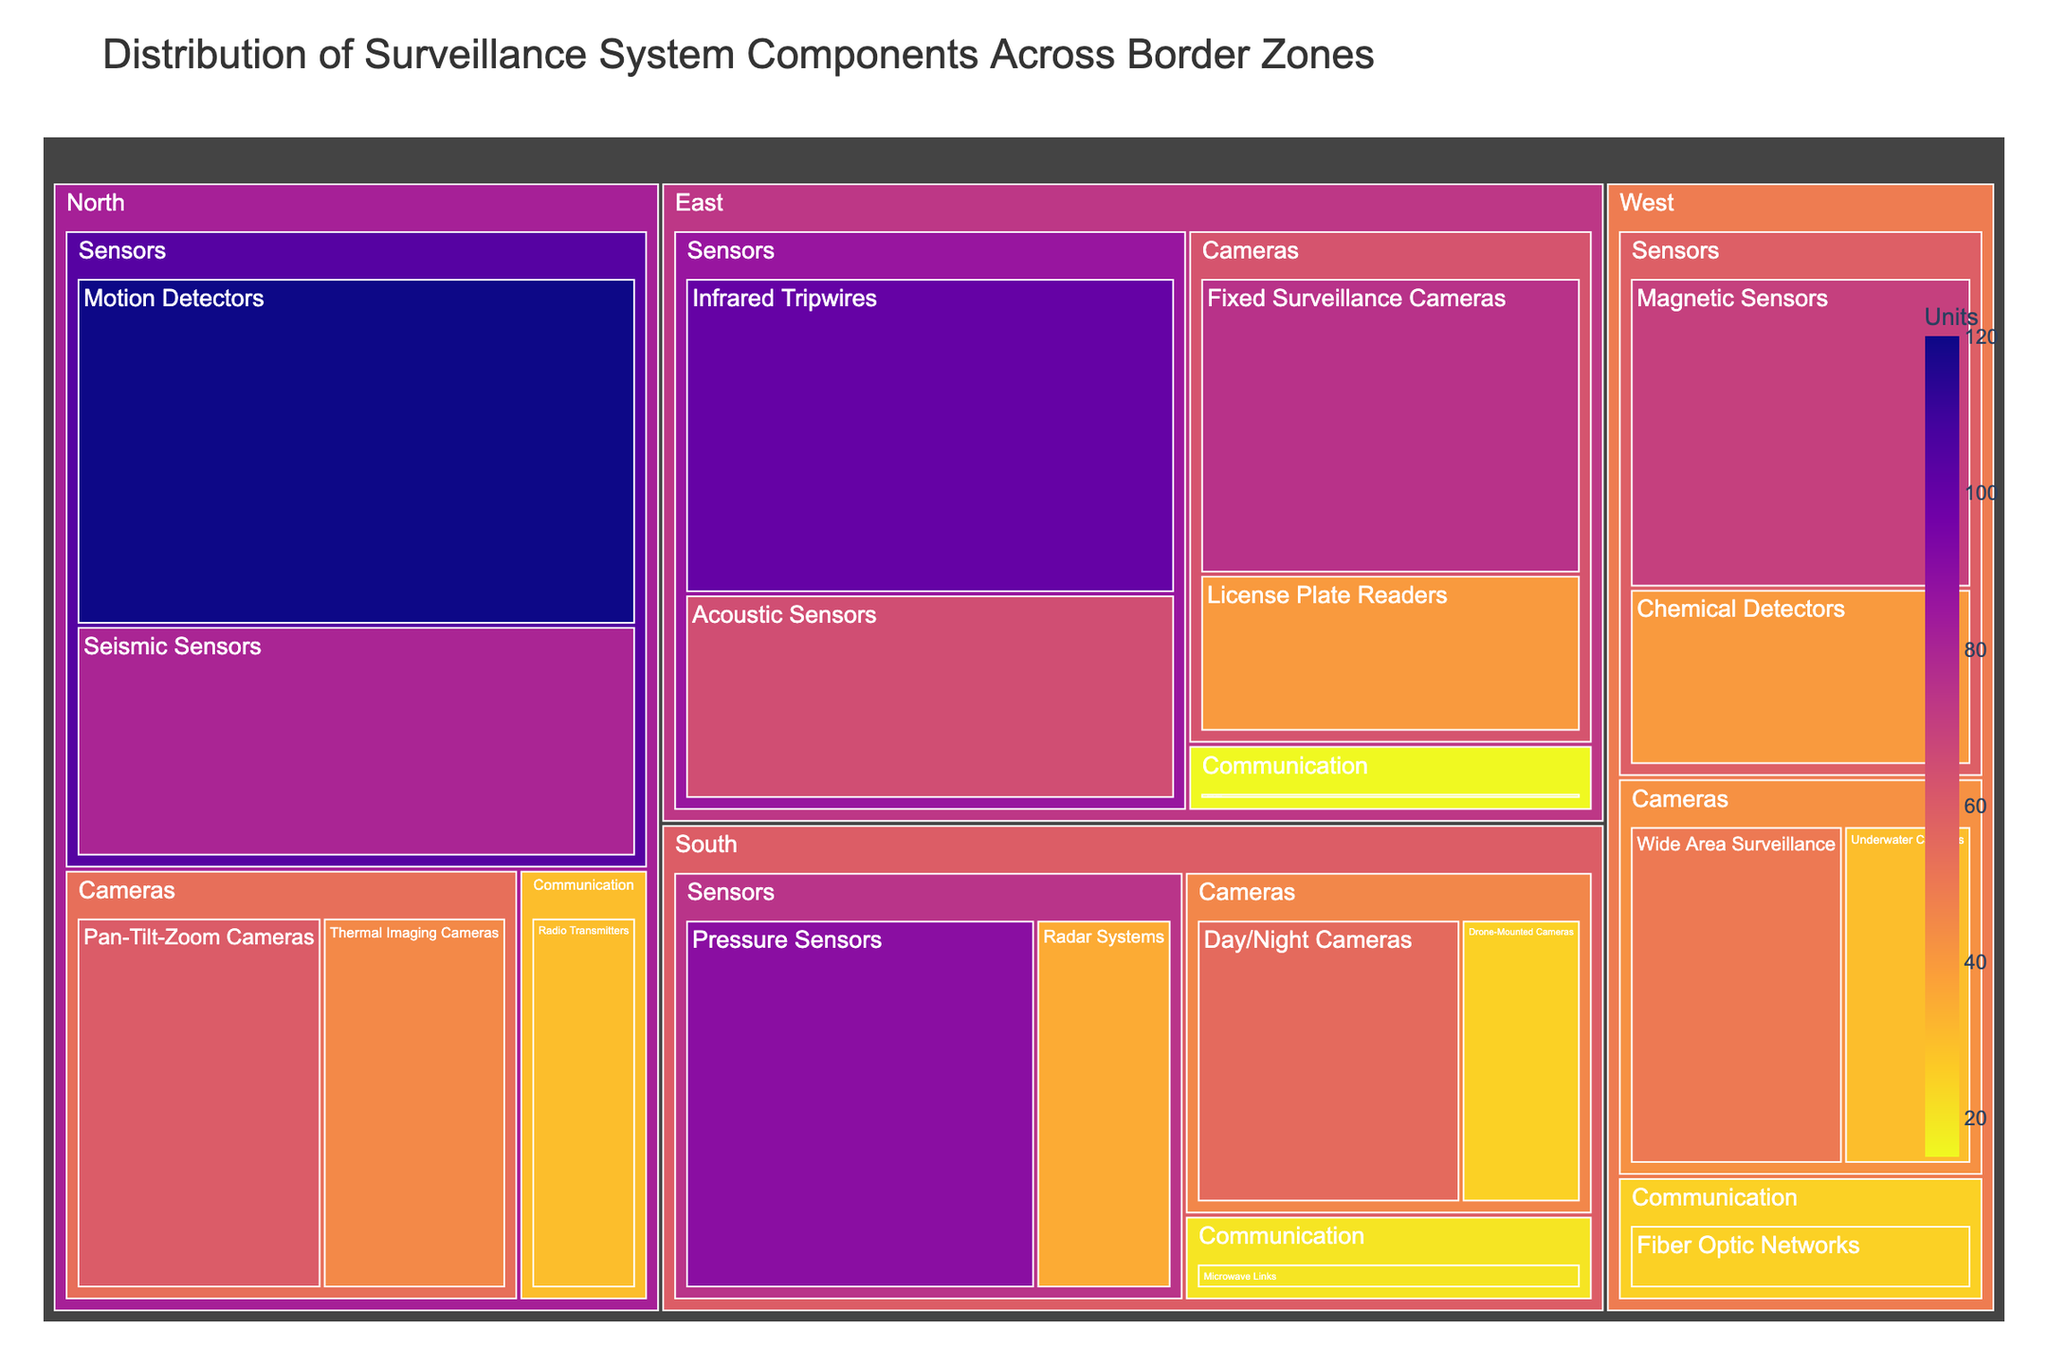What are the different categories of components in the North zone? The North zone includes cameras, sensors, and communication components. This can be seen by looking at the subdivisions under the North zone in the treemap.
Answer: Cameras, Sensors, Communication Which zone has the highest number of sensor units? By examining the larger rectangles representing sensor units within each zone, the North zone shows the highest number with a total of 200 units (120 motion detectors + 80 seismic sensors).
Answer: North How many total units of communication components are found across all zones? Summing up all communication units across the zones: North (30) + East (15) + South (20) + West (25) equals 90 units.
Answer: 90 Which zone contains the least number of camera units? By comparing the camera units across the zones, the South zone has 80 units (55 day/night cameras + 25 drone-mounted cameras), which is the least.
Answer: South What is the unit difference between the seismic sensors in the North zone and the radar systems in the South zone? The number of seismic sensors in the North zone (80) minus the number of radar systems in the South zone (35) results in a difference of 45.
Answer: 45 Which component within the East zone has the highest number of units? Observing the subdivisions in the East zone, infrared tripwires have the highest number with 100 units.
Answer: Infrared Tripwires Compare the number of units for thermal imaging cameras in the North zone with fixed surveillance cameras in the East zone. Which is higher? Thermal imaging cameras in the North zone have 45 units, while fixed surveillance cameras in the East zone have 75 units. Thus, fixed surveillance cameras are higher.
Answer: Fixed Surveillance Cameras What is the total number of camera units across all zones? Summing up the camera units across all zones: North (105) + East (115) + South (80) + West (80) results in a total of 380 units.
Answer: 380 Which zone has the largest variety of different components? By counting the unique components listed under each zone, the North and South zones both have five different components. They both tie for the largest variety.
Answer: North and South (tie) What’s the average number of units per component in the West zone? The West zone has 4 components with units: Wide Area Surveillance (50) + Underwater Cameras (30) + Magnetic Sensors (70) + Chemical Detectors (40) + Fiber Optic Networks (25). Adding them gives 215 units, and dividing this by 5 components gives an average of 43 units per component.
Answer: 43 